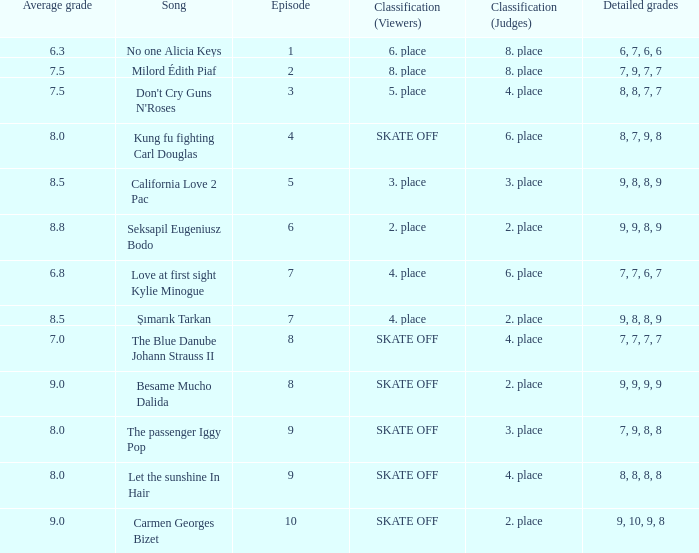Name the average grade for şımarık tarkan 8.5. 